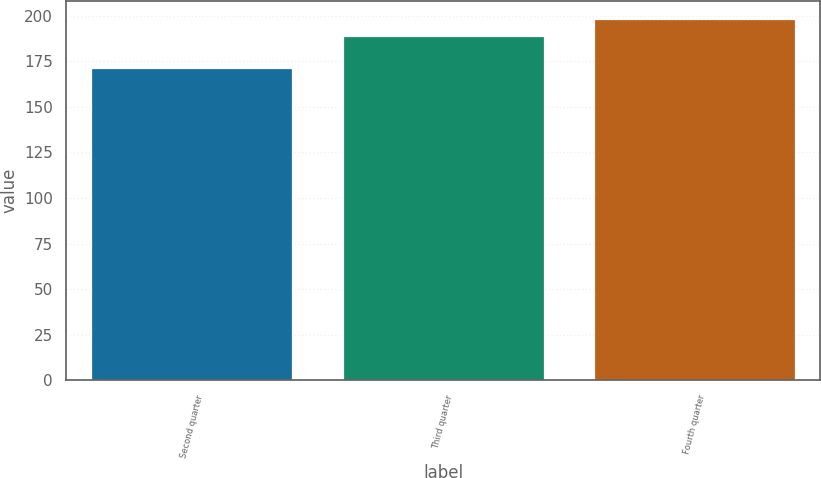Convert chart to OTSL. <chart><loc_0><loc_0><loc_500><loc_500><bar_chart><fcel>Second quarter<fcel>Third quarter<fcel>Fourth quarter<nl><fcel>171.08<fcel>188.58<fcel>198.06<nl></chart> 